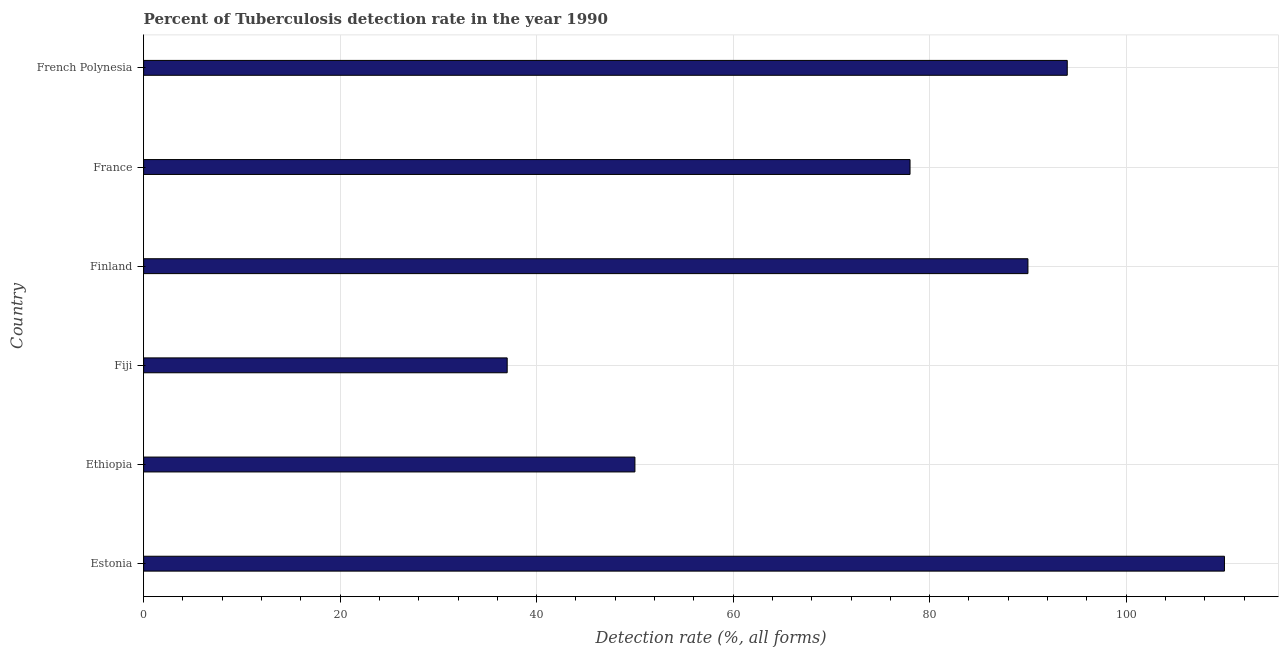Does the graph contain any zero values?
Ensure brevity in your answer.  No. What is the title of the graph?
Offer a terse response. Percent of Tuberculosis detection rate in the year 1990. What is the label or title of the X-axis?
Offer a very short reply. Detection rate (%, all forms). Across all countries, what is the maximum detection rate of tuberculosis?
Your response must be concise. 110. In which country was the detection rate of tuberculosis maximum?
Your answer should be compact. Estonia. In which country was the detection rate of tuberculosis minimum?
Offer a very short reply. Fiji. What is the sum of the detection rate of tuberculosis?
Your answer should be very brief. 459. What is the average detection rate of tuberculosis per country?
Give a very brief answer. 76.5. What is the median detection rate of tuberculosis?
Give a very brief answer. 84. In how many countries, is the detection rate of tuberculosis greater than 20 %?
Your answer should be very brief. 6. What is the ratio of the detection rate of tuberculosis in Ethiopia to that in Finland?
Provide a short and direct response. 0.56. Is the detection rate of tuberculosis in Estonia less than that in Finland?
Ensure brevity in your answer.  No. Is the difference between the detection rate of tuberculosis in Estonia and Finland greater than the difference between any two countries?
Offer a terse response. No. What is the difference between the highest and the second highest detection rate of tuberculosis?
Provide a succinct answer. 16. Is the sum of the detection rate of tuberculosis in Finland and French Polynesia greater than the maximum detection rate of tuberculosis across all countries?
Ensure brevity in your answer.  Yes. Are the values on the major ticks of X-axis written in scientific E-notation?
Your response must be concise. No. What is the Detection rate (%, all forms) in Estonia?
Make the answer very short. 110. What is the Detection rate (%, all forms) of Ethiopia?
Ensure brevity in your answer.  50. What is the Detection rate (%, all forms) of Finland?
Offer a terse response. 90. What is the Detection rate (%, all forms) in French Polynesia?
Your response must be concise. 94. What is the difference between the Detection rate (%, all forms) in Estonia and Ethiopia?
Your answer should be very brief. 60. What is the difference between the Detection rate (%, all forms) in Estonia and French Polynesia?
Keep it short and to the point. 16. What is the difference between the Detection rate (%, all forms) in Ethiopia and Fiji?
Your answer should be very brief. 13. What is the difference between the Detection rate (%, all forms) in Ethiopia and Finland?
Offer a very short reply. -40. What is the difference between the Detection rate (%, all forms) in Ethiopia and French Polynesia?
Ensure brevity in your answer.  -44. What is the difference between the Detection rate (%, all forms) in Fiji and Finland?
Offer a terse response. -53. What is the difference between the Detection rate (%, all forms) in Fiji and France?
Provide a succinct answer. -41. What is the difference between the Detection rate (%, all forms) in Fiji and French Polynesia?
Offer a terse response. -57. What is the difference between the Detection rate (%, all forms) in Finland and French Polynesia?
Offer a very short reply. -4. What is the ratio of the Detection rate (%, all forms) in Estonia to that in Fiji?
Give a very brief answer. 2.97. What is the ratio of the Detection rate (%, all forms) in Estonia to that in Finland?
Ensure brevity in your answer.  1.22. What is the ratio of the Detection rate (%, all forms) in Estonia to that in France?
Ensure brevity in your answer.  1.41. What is the ratio of the Detection rate (%, all forms) in Estonia to that in French Polynesia?
Your answer should be compact. 1.17. What is the ratio of the Detection rate (%, all forms) in Ethiopia to that in Fiji?
Make the answer very short. 1.35. What is the ratio of the Detection rate (%, all forms) in Ethiopia to that in Finland?
Provide a short and direct response. 0.56. What is the ratio of the Detection rate (%, all forms) in Ethiopia to that in France?
Offer a terse response. 0.64. What is the ratio of the Detection rate (%, all forms) in Ethiopia to that in French Polynesia?
Your response must be concise. 0.53. What is the ratio of the Detection rate (%, all forms) in Fiji to that in Finland?
Make the answer very short. 0.41. What is the ratio of the Detection rate (%, all forms) in Fiji to that in France?
Make the answer very short. 0.47. What is the ratio of the Detection rate (%, all forms) in Fiji to that in French Polynesia?
Provide a short and direct response. 0.39. What is the ratio of the Detection rate (%, all forms) in Finland to that in France?
Offer a terse response. 1.15. What is the ratio of the Detection rate (%, all forms) in Finland to that in French Polynesia?
Your response must be concise. 0.96. What is the ratio of the Detection rate (%, all forms) in France to that in French Polynesia?
Your response must be concise. 0.83. 